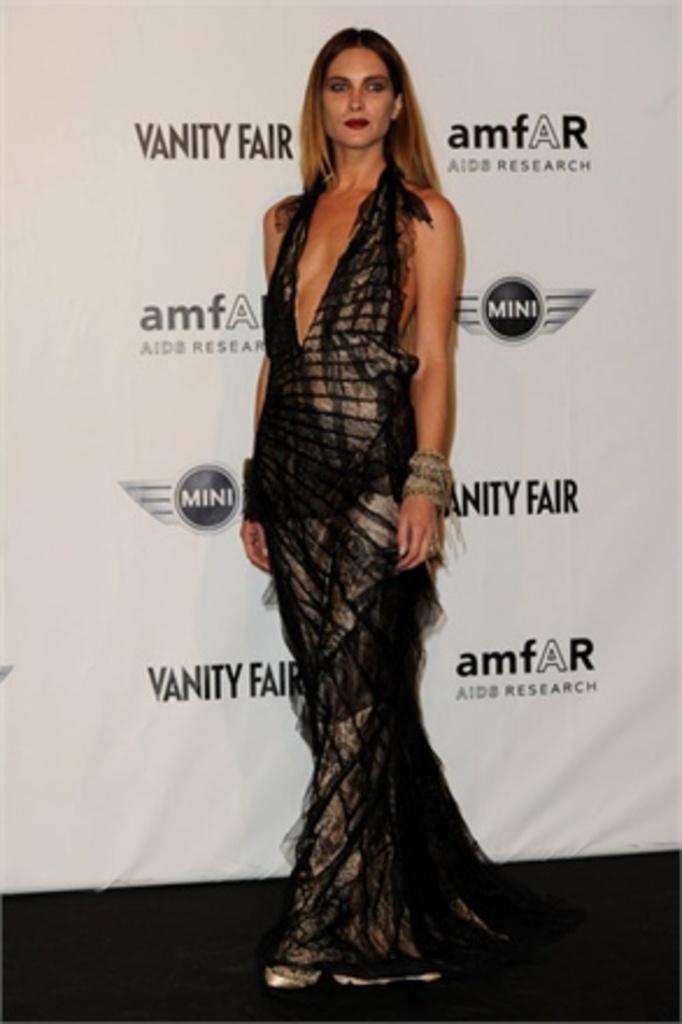Who is the main subject in the image? There is a woman in the image. What is the woman doing in the image? The woman is standing and posing for the picture. What else can be seen in the image besides the woman? There is a banner in the image. Can you describe the banner in the image? The banner has text on it. What type of juice is being served at the event mentioned on the banner? There is no mention of juice or an event in the image, so it cannot be determined from the image. 